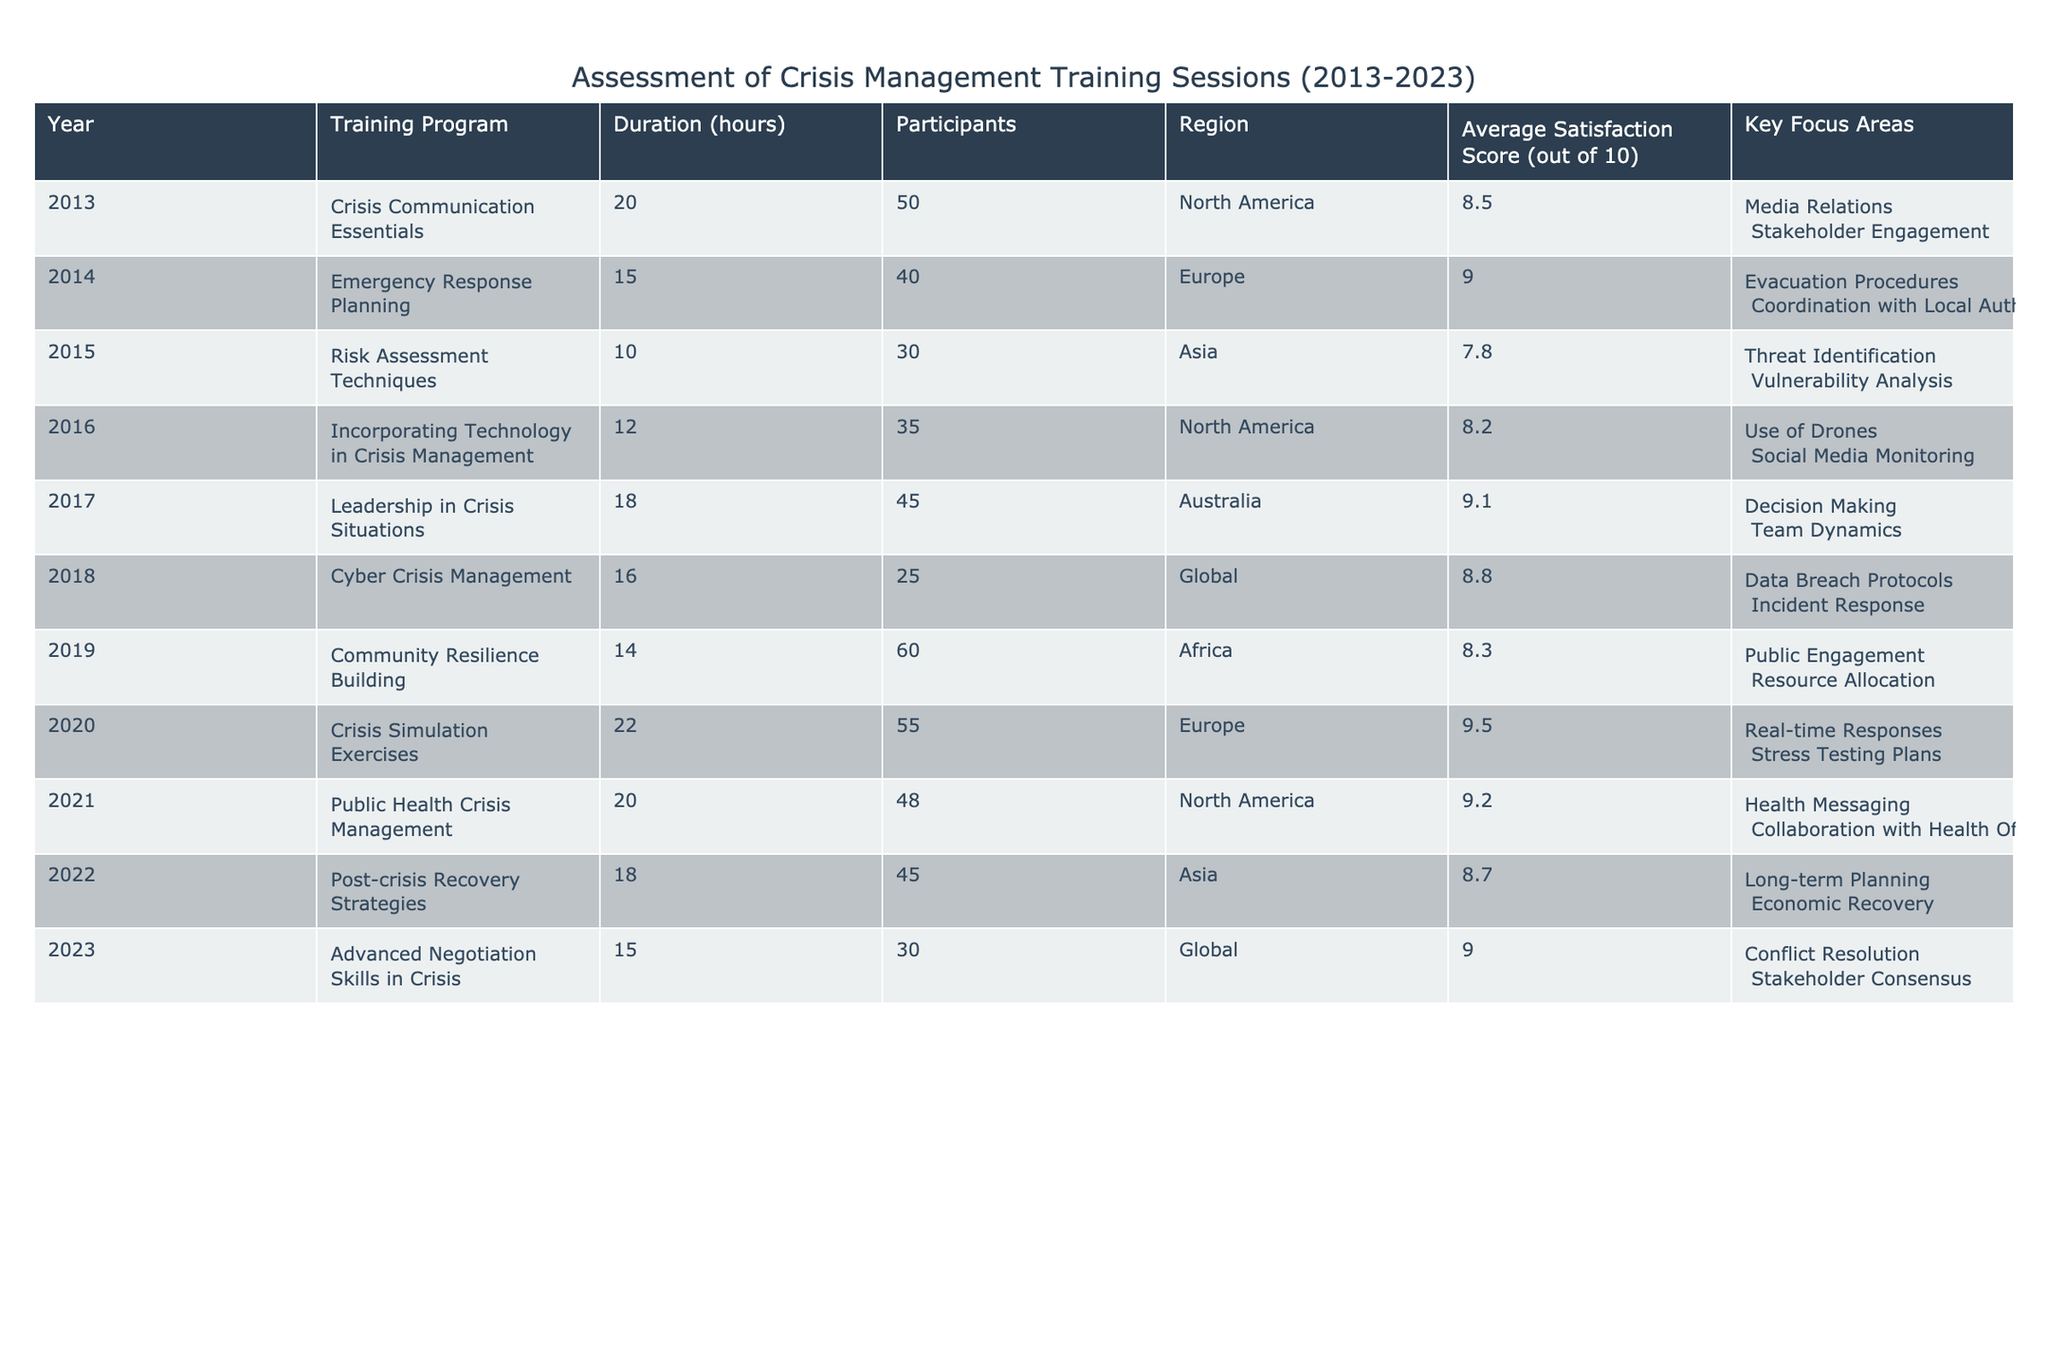What was the average satisfaction score for training sessions in North America over the decade? To find the average satisfaction score for North America, we need the scores from the training programs conducted in this region between 2013 and 2023, which are 8.5, 8.2, 9.1, and 9.2. The average is calculated by summing these scores: 8.5 + 8.2 + 9.1 + 9.2 = 35. The count of programs is 4, so the average score is 35 / 4 = 8.75.
Answer: 8.75 Which training program had the highest number of participants? The training programs' participant numbers are as follows: 50, 40, 30, 35, 45, 25, 60, 55, 48, 45, and 30. The highest number is 60, which corresponds to the "Community Resilience Building" program conducted in Africa in 2019.
Answer: Community Resilience Building Was there a training program in 2018 focused on Cyber Crisis Management? To verify this, we check the year 2018 in the table. The training program listed is "Cyber Crisis Management," which indeed focuses on this area. Therefore, the statement is true.
Answer: Yes What is the total duration of all training programs conducted in Europe? The training programs in Europe and their durations are 15 hours for "Emergency Response Planning" in 2014, 22 hours for "Crisis Simulation Exercises" in 2020, and 20 hours for "Public Health Crisis Management" in 2021. To find the total duration, we sum these hours: 15 + 22 + 20 = 57 hours.
Answer: 57 Which region had the lowest average satisfaction score? We need to calculate the average satisfaction score for each region. The scores are: North America (8.75), Europe (9.25), Asia (8.25), Australia (9.1), Africa (8.3), and Global (8.9). The lowest average is from Asia, which is 8.25.
Answer: Asia How many training programs focused on leadership in crisis situations? The only instance of 'Leadership in Crisis Situations' listed is from 2017, indicating that there was just one training program dedicated to this topic over the decade.
Answer: 1 What key focus areas were included in the training program with the longest duration? The longest training program is "Crisis Simulation Exercises" with a duration of 22 hours. It focuses on "Real-time Responses" and "Stress Testing Plans" as key areas.
Answer: Real-time Responses; Stress Testing Plans What is the difference between the highest and lowest satisfaction scores across all training programs? The highest satisfaction score is 9.5 for "Crisis Simulation Exercises" in 2020, and the lowest satisfaction score is 7.8 for "Risk Assessment Techniques" in 2015. The difference is 9.5 - 7.8 = 1.7.
Answer: 1.7 